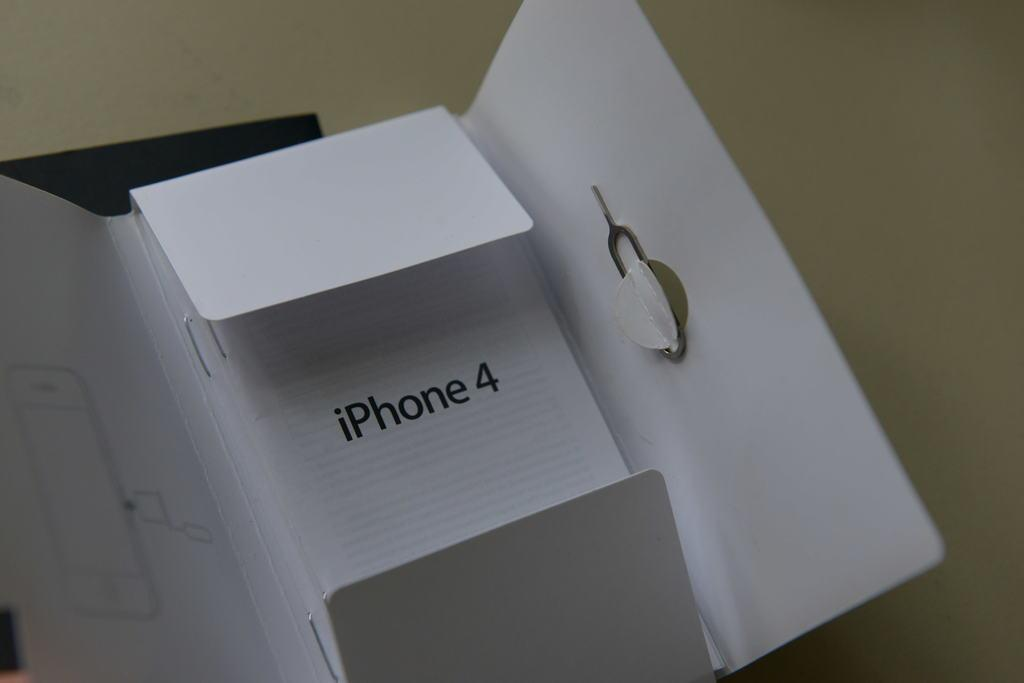<image>
Write a terse but informative summary of the picture. An open cardboard holder is made to fit an iPhone 4. 